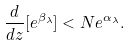<formula> <loc_0><loc_0><loc_500><loc_500>\frac { d } { d z } [ e ^ { \beta _ { \lambda } } ] < N e ^ { \alpha _ { \lambda } } .</formula> 